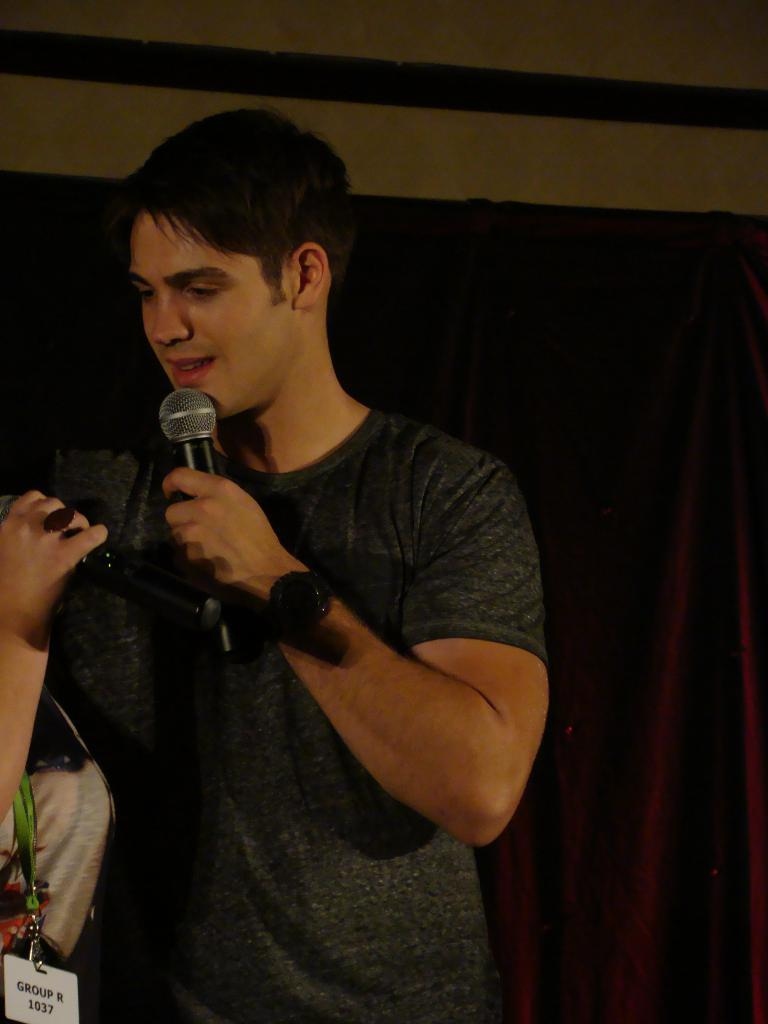Who or what is present in the image? There is a person in the image. What is the person doing in the image? The person is smiling and holding a microphone. What can be seen in the background of the image? There is a sheet attached to the wall in the background of the image. What type of stew is being served on the person's toes in the image? There is no stew or toes present in the image; it features a person holding a microphone with a sheet in the background. 